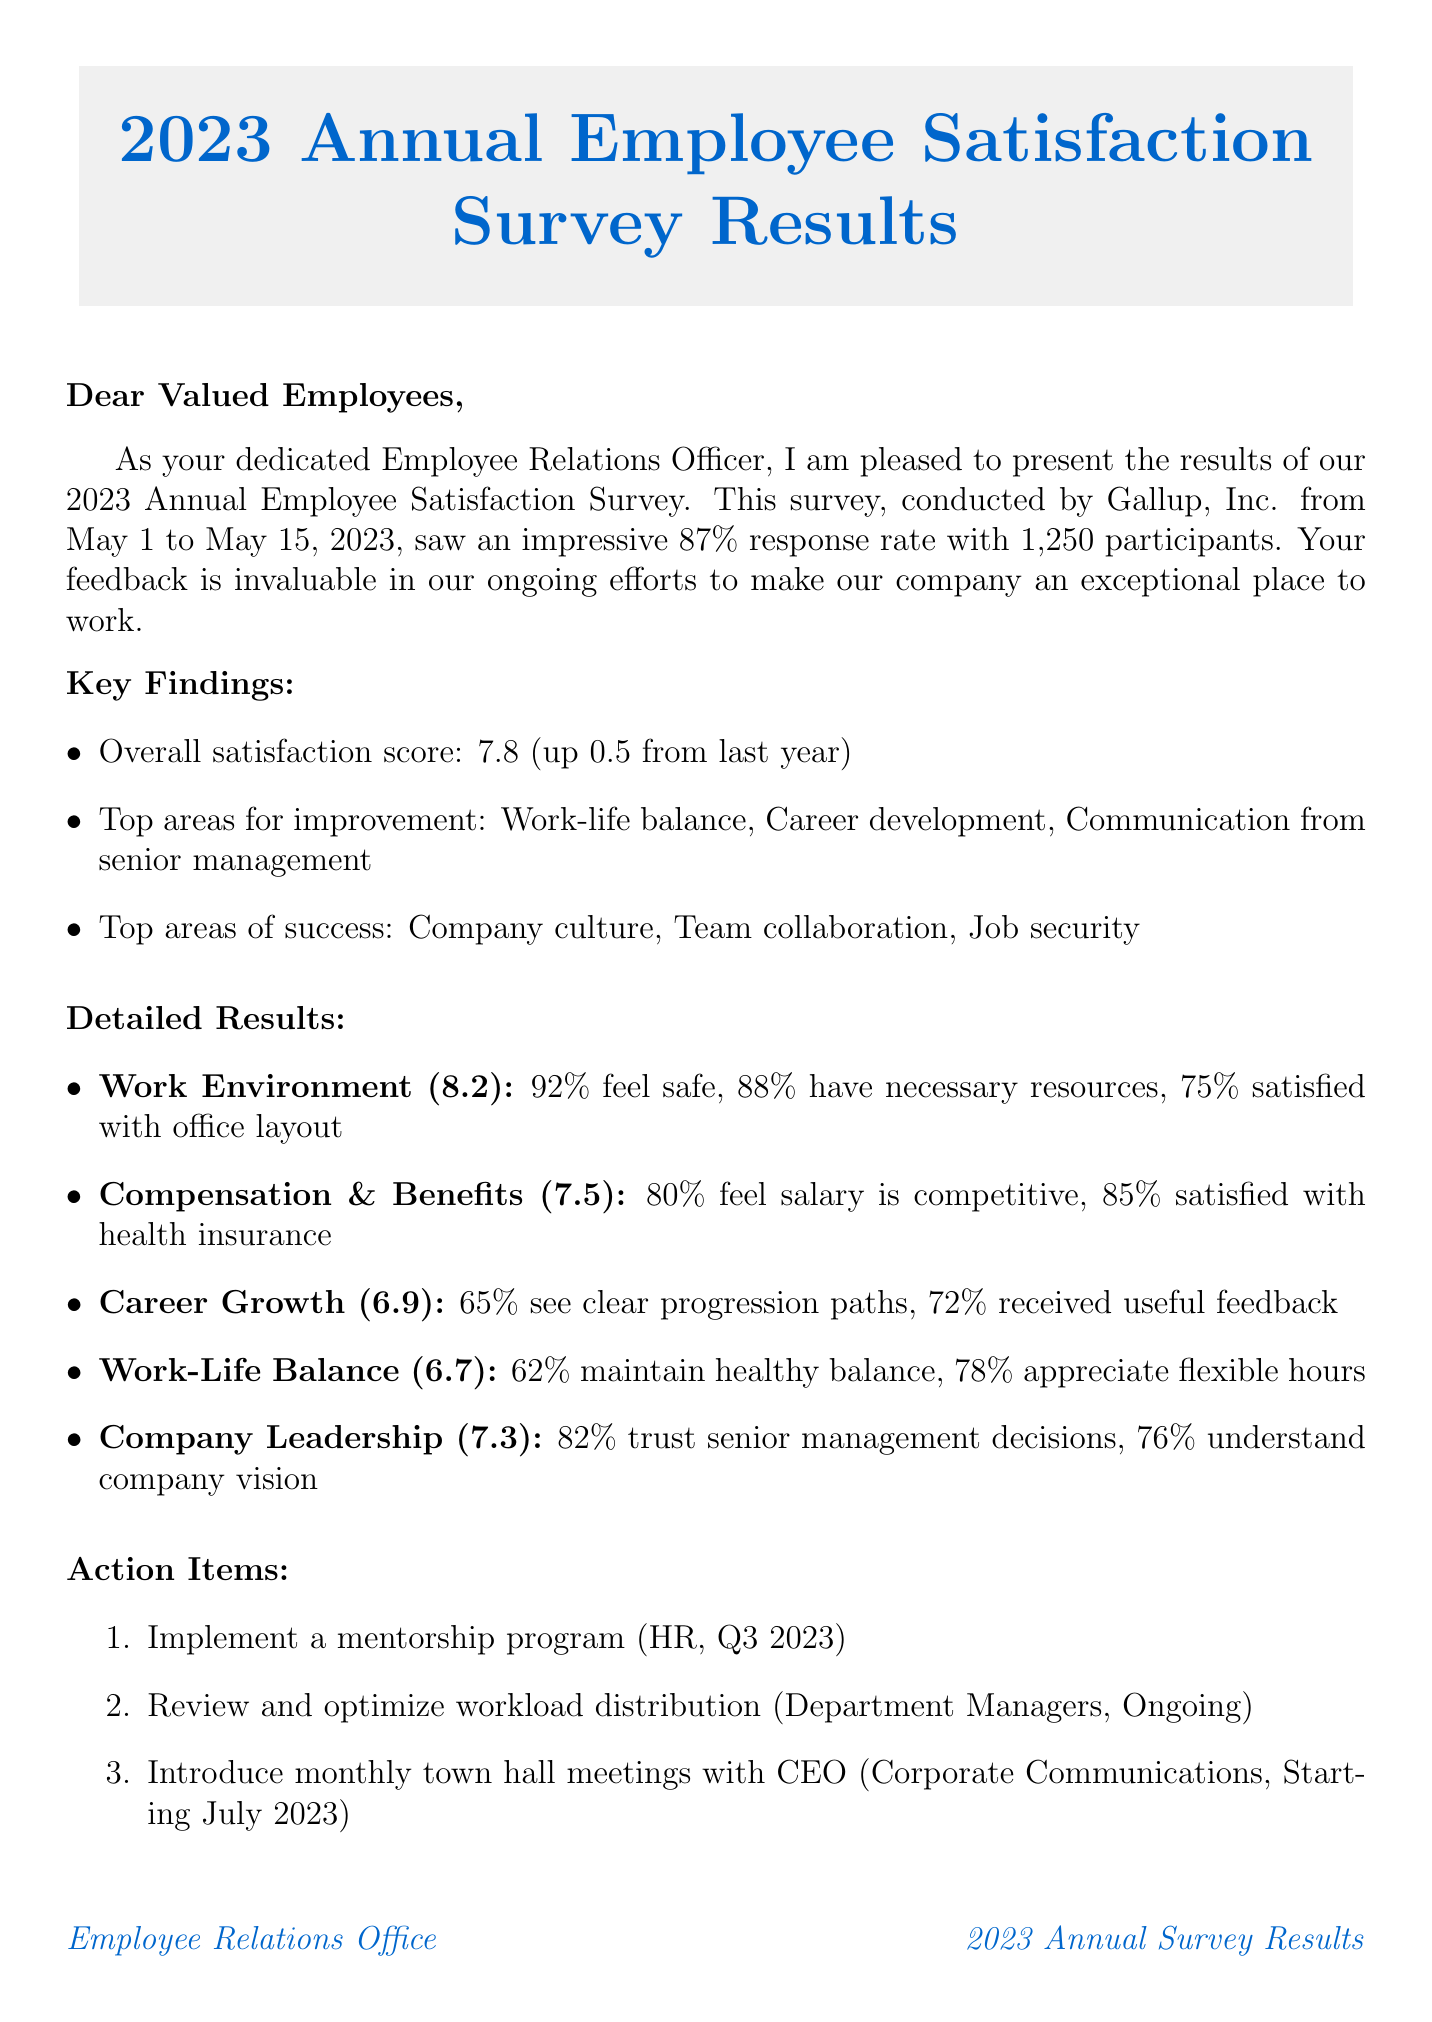what was the response rate of the survey? The response rate is mentioned in the survey overview section of the document.
Answer: 87% who conducted the employee satisfaction survey? The name of the organization that conducted the survey is provided in the survey overview.
Answer: Gallup, Inc what is the overall satisfaction score for this year? The overall satisfaction score is listed in the key findings section of the document.
Answer: 7.8 what area had the highest score? The detailed results include scores for various areas, highlighting the highest one.
Answer: Work Environment what action item is assigned to the Human Resources Department? The action items section specifies tasks and who is responsible for them.
Answer: Implement a mentorship program how much did overall satisfaction improve from last year? The change in overall satisfaction score is given in the key findings.
Answer: +0.5 which area of improvement received a score of 6.7? The detailed results provide scores for specific improvement areas.
Answer: Work-Life Balance how did the Agile Project Management Training impact team collaboration? The success stories detail the impact of various initiatives on employee satisfaction.
Answer: Improved team collaboration score by 22% what will be the focus of the next steps? The conclusion section summarizes the focus areas for future action.
Answer: Implementing the identified action items 